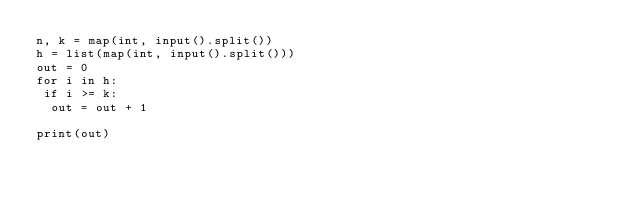Convert code to text. <code><loc_0><loc_0><loc_500><loc_500><_Python_>n, k = map(int, input().split())
h = list(map(int, input().split()))
out = 0
for i in h:
 if i >= k:
  out = out + 1
  
print(out)</code> 